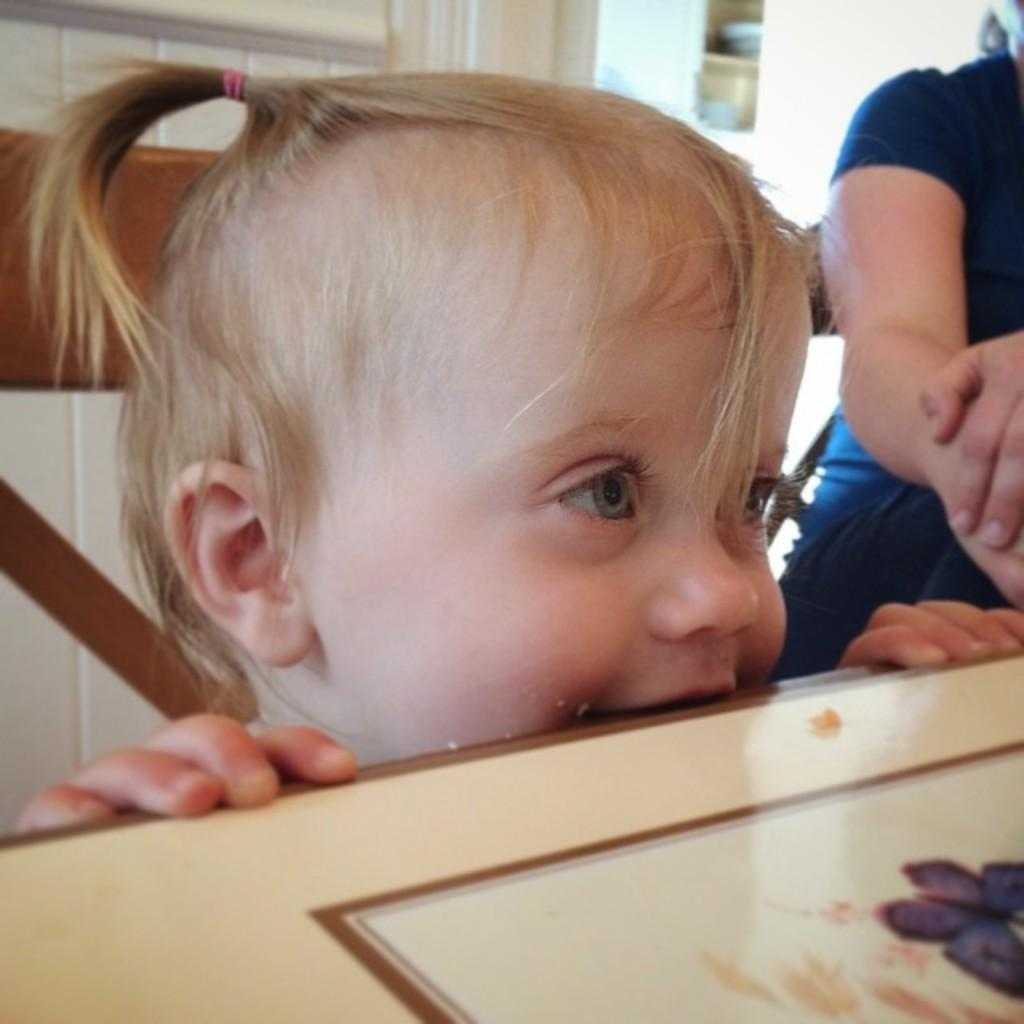Who is the main subject in the image? There is a girl in the image. What object can be seen in the image besides the girl? There is a table in the image. What is visible in the background of the image? There is a door in the background of the image. Who else is present in the image? There is a lady on the right side of the image. What type of tent can be seen in the image? There is no tent present in the image. What kind of dirt is visible on the girl's shoes in the image? There is no dirt visible on the girl's shoes in the image. 